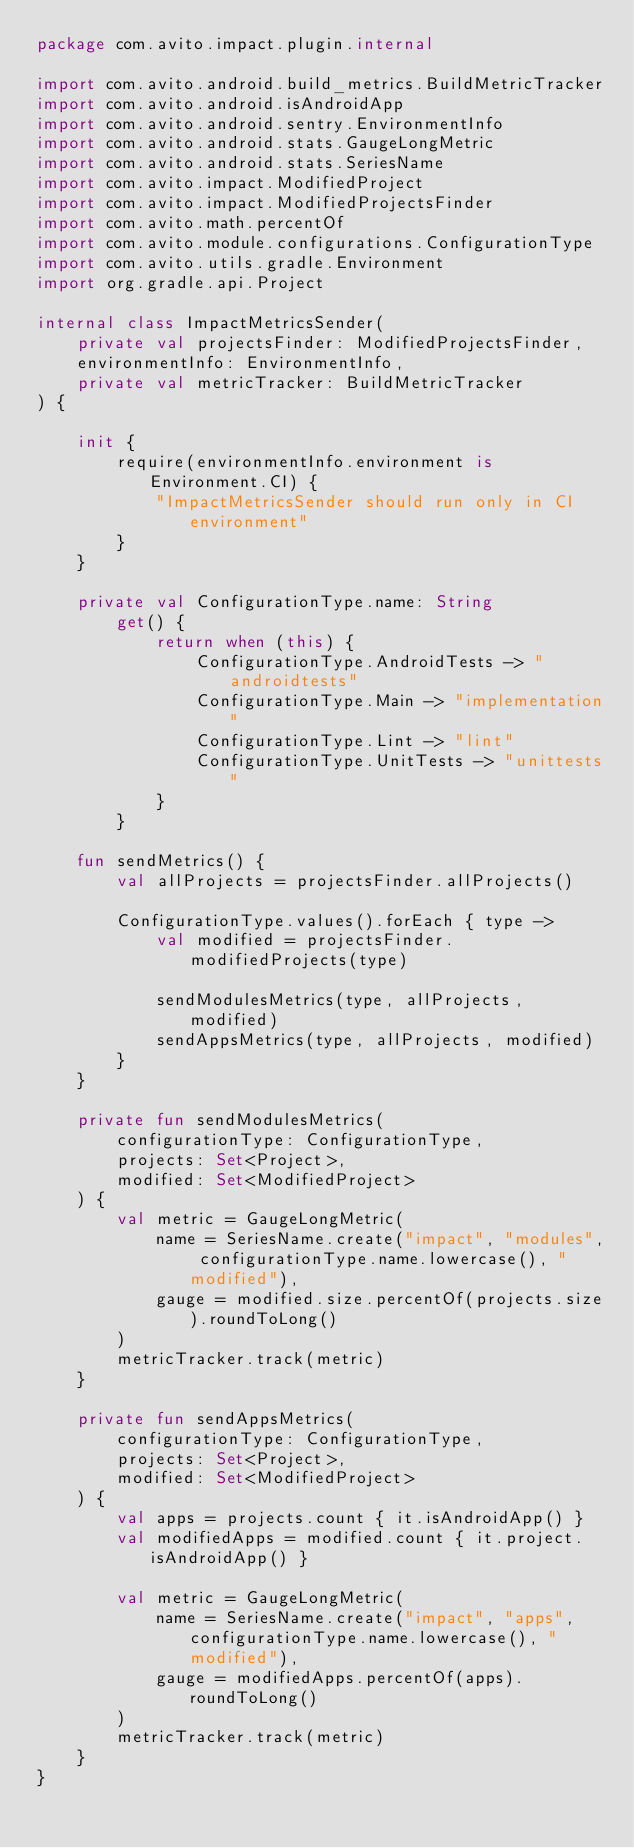<code> <loc_0><loc_0><loc_500><loc_500><_Kotlin_>package com.avito.impact.plugin.internal

import com.avito.android.build_metrics.BuildMetricTracker
import com.avito.android.isAndroidApp
import com.avito.android.sentry.EnvironmentInfo
import com.avito.android.stats.GaugeLongMetric
import com.avito.android.stats.SeriesName
import com.avito.impact.ModifiedProject
import com.avito.impact.ModifiedProjectsFinder
import com.avito.math.percentOf
import com.avito.module.configurations.ConfigurationType
import com.avito.utils.gradle.Environment
import org.gradle.api.Project

internal class ImpactMetricsSender(
    private val projectsFinder: ModifiedProjectsFinder,
    environmentInfo: EnvironmentInfo,
    private val metricTracker: BuildMetricTracker
) {

    init {
        require(environmentInfo.environment is Environment.CI) {
            "ImpactMetricsSender should run only in CI environment"
        }
    }

    private val ConfigurationType.name: String
        get() {
            return when (this) {
                ConfigurationType.AndroidTests -> "androidtests"
                ConfigurationType.Main -> "implementation"
                ConfigurationType.Lint -> "lint"
                ConfigurationType.UnitTests -> "unittests"
            }
        }

    fun sendMetrics() {
        val allProjects = projectsFinder.allProjects()

        ConfigurationType.values().forEach { type ->
            val modified = projectsFinder.modifiedProjects(type)

            sendModulesMetrics(type, allProjects, modified)
            sendAppsMetrics(type, allProjects, modified)
        }
    }

    private fun sendModulesMetrics(
        configurationType: ConfigurationType,
        projects: Set<Project>,
        modified: Set<ModifiedProject>
    ) {
        val metric = GaugeLongMetric(
            name = SeriesName.create("impact", "modules", configurationType.name.lowercase(), "modified"),
            gauge = modified.size.percentOf(projects.size).roundToLong()
        )
        metricTracker.track(metric)
    }

    private fun sendAppsMetrics(
        configurationType: ConfigurationType,
        projects: Set<Project>,
        modified: Set<ModifiedProject>
    ) {
        val apps = projects.count { it.isAndroidApp() }
        val modifiedApps = modified.count { it.project.isAndroidApp() }

        val metric = GaugeLongMetric(
            name = SeriesName.create("impact", "apps", configurationType.name.lowercase(), "modified"),
            gauge = modifiedApps.percentOf(apps).roundToLong()
        )
        metricTracker.track(metric)
    }
}
</code> 